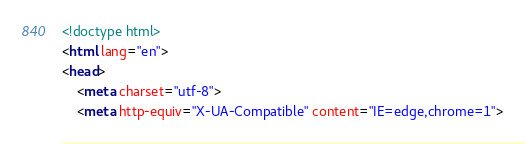Convert code to text. <code><loc_0><loc_0><loc_500><loc_500><_HTML_><!doctype html>
<html lang="en">
<head>
    <meta charset="utf-8">
    <meta http-equiv="X-UA-Compatible" content="IE=edge,chrome=1"></code> 